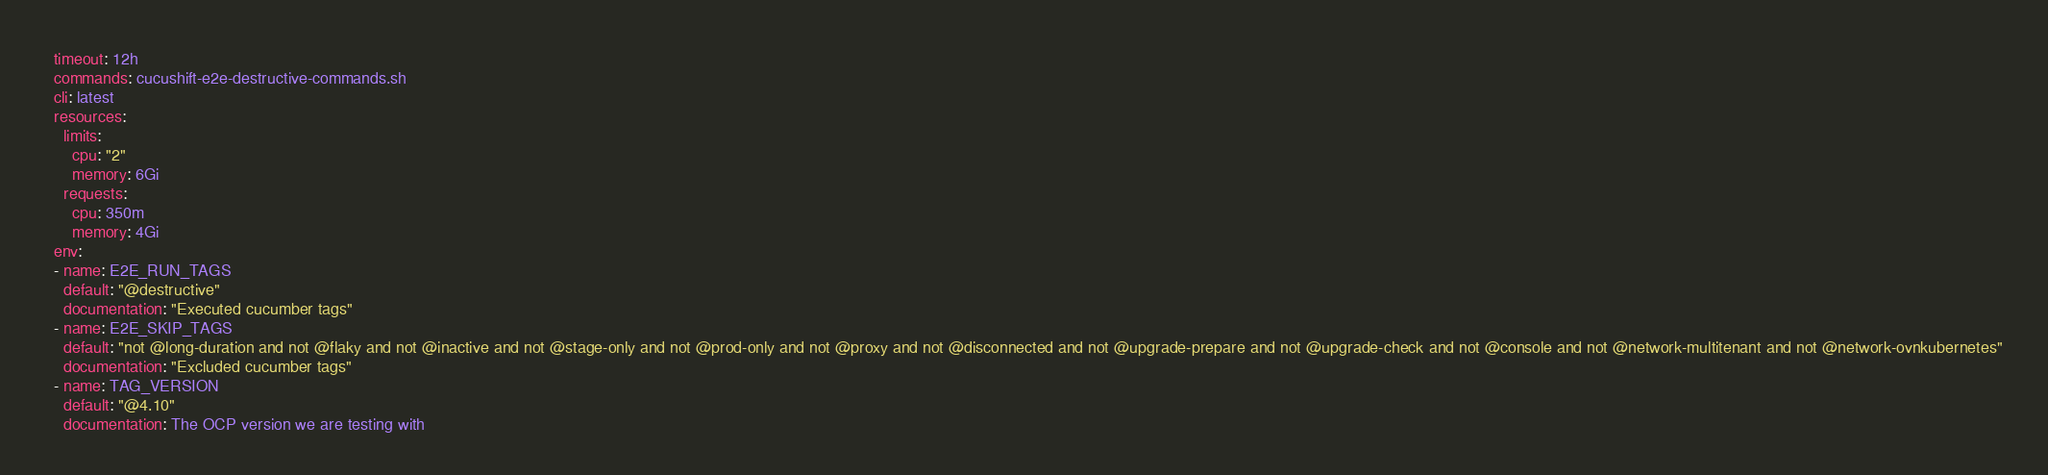<code> <loc_0><loc_0><loc_500><loc_500><_YAML_>  timeout: 12h
  commands: cucushift-e2e-destructive-commands.sh
  cli: latest
  resources:
    limits:
      cpu: "2"
      memory: 6Gi
    requests:
      cpu: 350m
      memory: 4Gi
  env:
  - name: E2E_RUN_TAGS
    default: "@destructive"
    documentation: "Executed cucumber tags"
  - name: E2E_SKIP_TAGS
    default: "not @long-duration and not @flaky and not @inactive and not @stage-only and not @prod-only and not @proxy and not @disconnected and not @upgrade-prepare and not @upgrade-check and not @console and not @network-multitenant and not @network-ovnkubernetes"
    documentation: "Excluded cucumber tags"
  - name: TAG_VERSION
    default: "@4.10"
    documentation: The OCP version we are testing with
</code> 